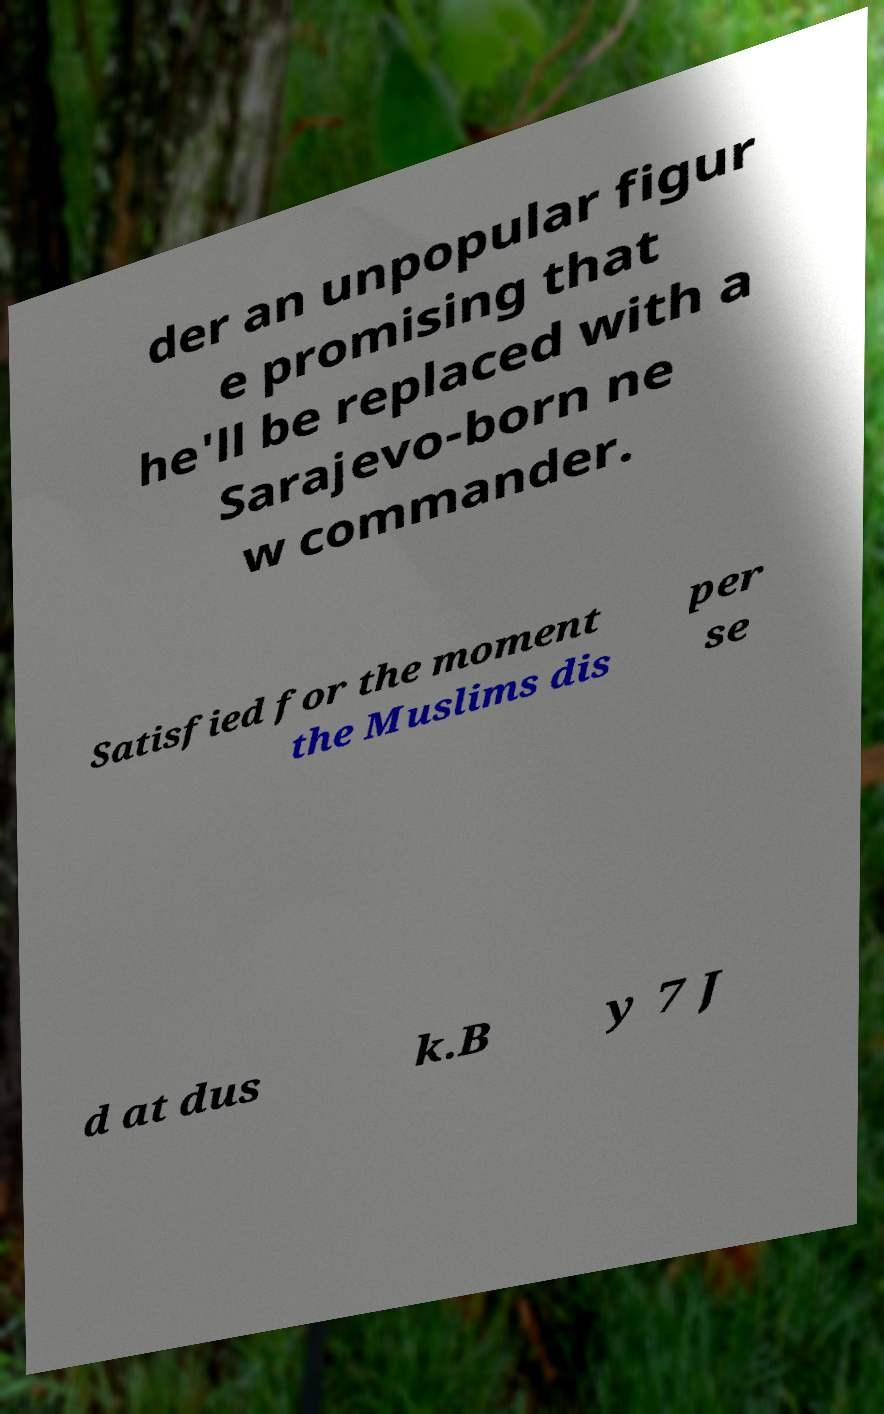Please read and relay the text visible in this image. What does it say? der an unpopular figur e promising that he'll be replaced with a Sarajevo-born ne w commander. Satisfied for the moment the Muslims dis per se d at dus k.B y 7 J 